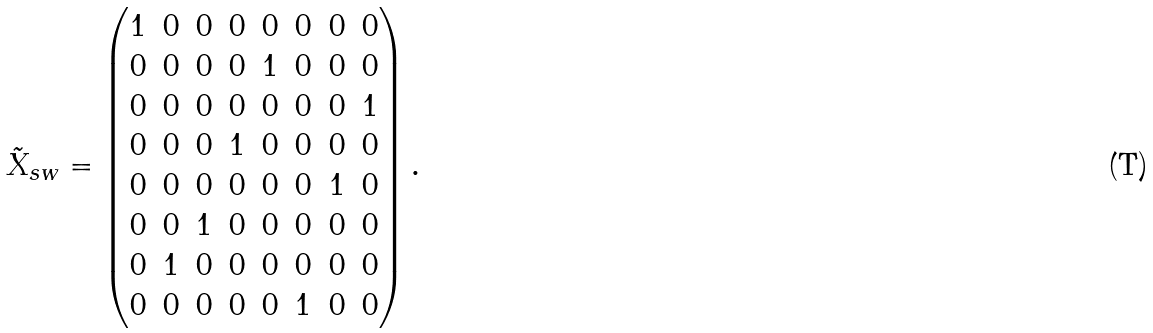<formula> <loc_0><loc_0><loc_500><loc_500>\tilde { X } _ { s w } = \begin{pmatrix} 1 & 0 & 0 & 0 & 0 & 0 & 0 & 0 \\ 0 & 0 & 0 & 0 & 1 & 0 & 0 & 0 \\ 0 & 0 & 0 & 0 & 0 & 0 & 0 & 1 \\ 0 & 0 & 0 & 1 & 0 & 0 & 0 & 0 \\ 0 & 0 & 0 & 0 & 0 & 0 & 1 & 0 \\ 0 & 0 & 1 & 0 & 0 & 0 & 0 & 0 \\ 0 & 1 & 0 & 0 & 0 & 0 & 0 & 0 \\ 0 & 0 & 0 & 0 & 0 & 1 & 0 & 0 \\ \end{pmatrix} .</formula> 